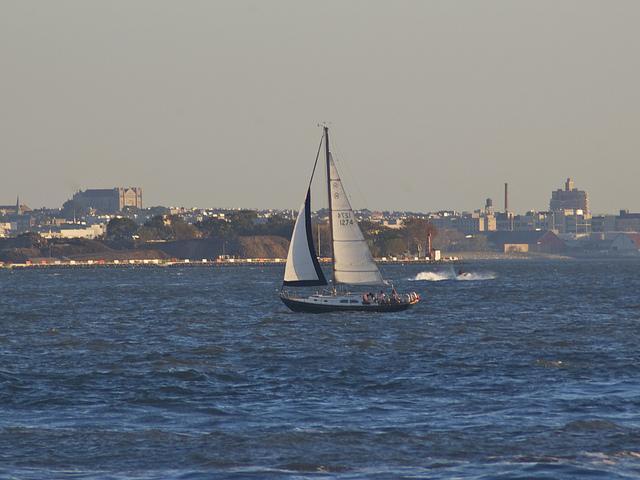How many horses are in the picture?
Give a very brief answer. 0. 